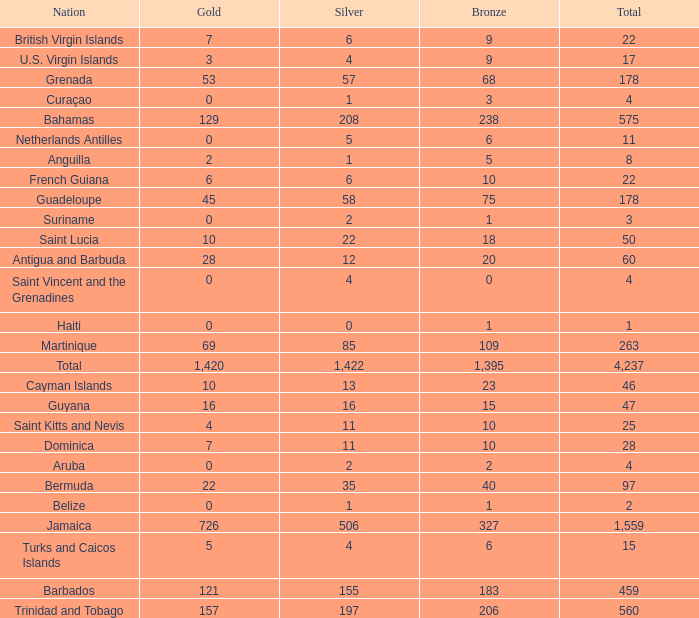What Nation has a Bronze that is smaller than 10 with a Silver of 5? Netherlands Antilles. 